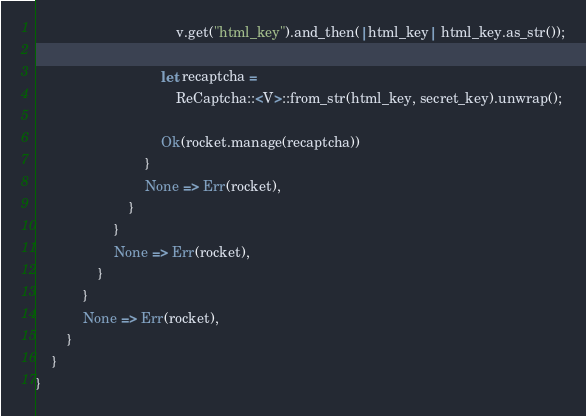<code> <loc_0><loc_0><loc_500><loc_500><_Rust_>                                    v.get("html_key").and_then(|html_key| html_key.as_str());

                                let recaptcha =
                                    ReCaptcha::<V>::from_str(html_key, secret_key).unwrap();

                                Ok(rocket.manage(recaptcha))
                            }
                            None => Err(rocket),
                        }
                    }
                    None => Err(rocket),
                }
            }
            None => Err(rocket),
        }
    }
}
</code> 